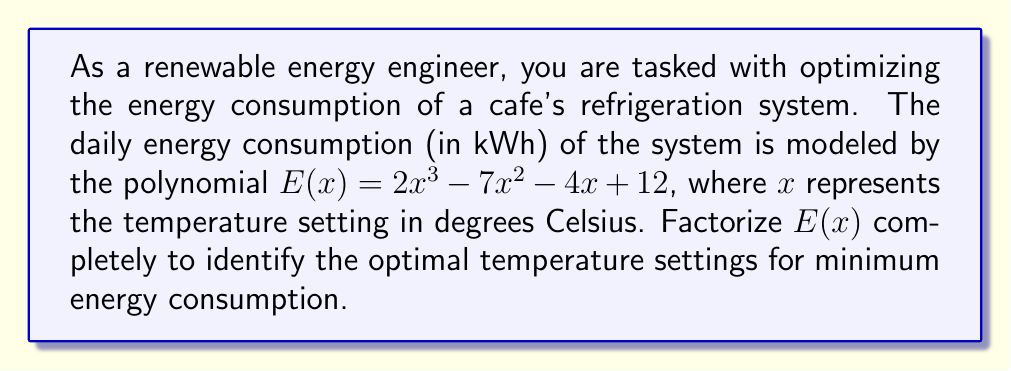Can you solve this math problem? To factorize the polynomial $E(x) = 2x^3 - 7x^2 - 4x + 12$, we'll follow these steps:

1) First, let's check if there's a common factor:
   $2x^3 - 7x^2 - 4x + 12$
   There's no common factor for all terms.

2) Next, we'll use the rational root theorem to find potential roots. The potential rational roots are the factors of the constant term (12) divided by the factors of the leading coefficient (2):
   $\pm 1, \pm 2, \pm 3, \pm 4, \pm 6, \pm 12, \pm \frac{1}{2}, \pm 1, \pm \frac{3}{2}, \pm 2, \pm 3, \pm 6$

3) Testing these values, we find that $x = 2$ is a root. So $(x - 2)$ is a factor.

4) Divide the polynomial by $(x - 2)$:
   $\frac{2x^3 - 7x^2 - 4x + 12}{x - 2} = 2x^2 - 3x - 6$

5) Now we have: $E(x) = (x - 2)(2x^2 - 3x - 6)$

6) Let's factorize the quadratic part $2x^2 - 3x - 6$:
   a) Find the product of $a$ and $c$: $2 \cdot (-6) = -12$
   b) Find two numbers that multiply to give -12 and add to give -3: 3 and -6
   c) Rewrite the middle term: $2x^2 + 3x - 6x - 6$
   d) Group and factor: $(2x^2 + 3x) + (-6x - 6)$
                        $x(2x + 3) - 2(3x + 3)$
                        $x(2x + 3) - 2(x + 1)$
   e) Factor out $(2x + 3)$: $(2x + 3)(x - 2)$

7) Therefore, the complete factorization is:
   $E(x) = (x - 2)(2x + 3)(x - 2)$
   $E(x) = (x - 2)^2(2x + 3)$

The roots of this polynomial (where $E(x) = 0$) are $x = 2$ (double root) and $x = -\frac{3}{2}$. These represent the temperature settings where energy consumption is zero, which is not practically possible. The optimal temperature for minimum energy consumption would lie between these values.
Answer: $E(x) = (x - 2)^2(2x + 3)$ 